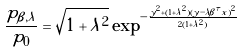Convert formula to latex. <formula><loc_0><loc_0><loc_500><loc_500>\frac { p _ { \beta , \lambda } } { p _ { 0 } } = \sqrt { 1 + \lambda ^ { 2 } } \exp ^ { - \frac { y ^ { 2 } + ( 1 + \lambda ^ { 2 } ) ( y - \lambda \beta ^ { \tau } x ) ^ { 2 } } { 2 ( 1 + \lambda ^ { 2 } ) } }</formula> 